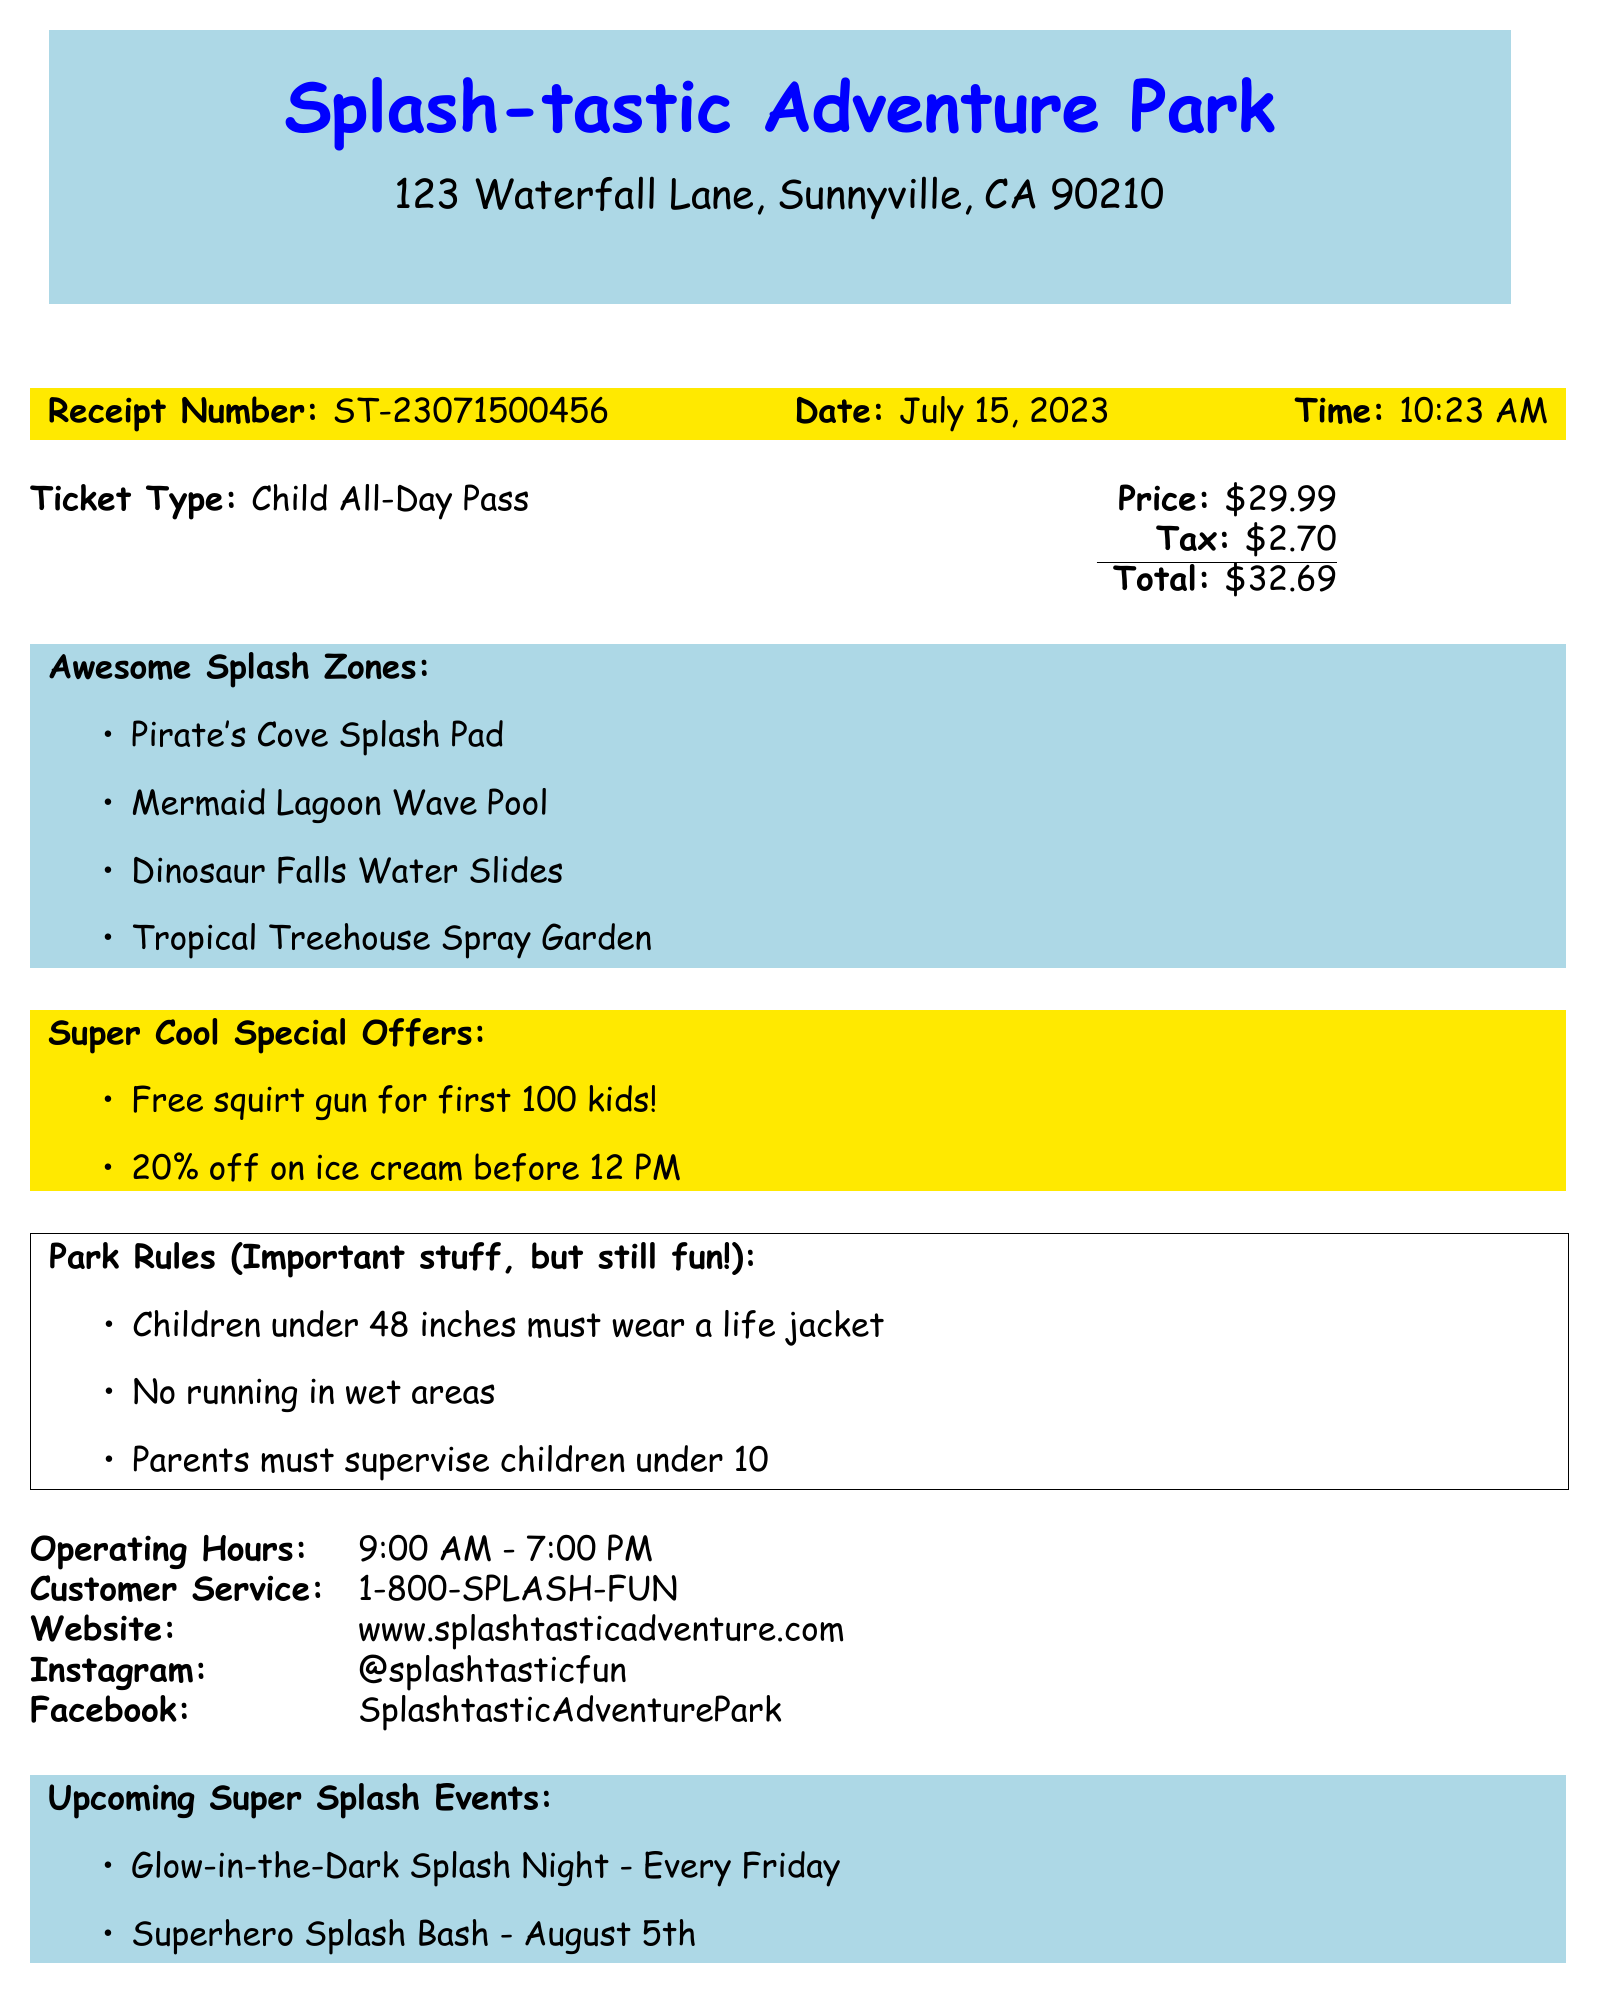What is the name of the water park? The name of the water park is mentioned at the top of the document.
Answer: Splash-tastic Adventure Park What is the price of the Child All-Day Pass? The ticket price is listed in the ticket information section.
Answer: $29.99 What is the tax amount included in the total? The tax amount is specified right under the price in the document.
Answer: $2.70 What are the operating hours of the park? The operating hours can be found in the table at the bottom of the document.
Answer: 9:00 AM - 7:00 PM Which special offer is available for ice cream? The special offers section mentions a discount on ice cream.
Answer: 20% off on ice cream before 12 PM How many splash zones are mentioned in the document? The document lists the splash zones in a bulleted list, counting them gives the answer.
Answer: 4 What must children under 48 inches wear? The park rules section states a requirement for children based on their height.
Answer: A life jacket What is the phone number for customer service? The customer service contact information is included near the operating hours.
Answer: 1-800-SPLASH-FUN What upcoming event happens every Friday? The upcoming events section indicates a repeating event every week.
Answer: Glow-in-the-Dark Splash Night 